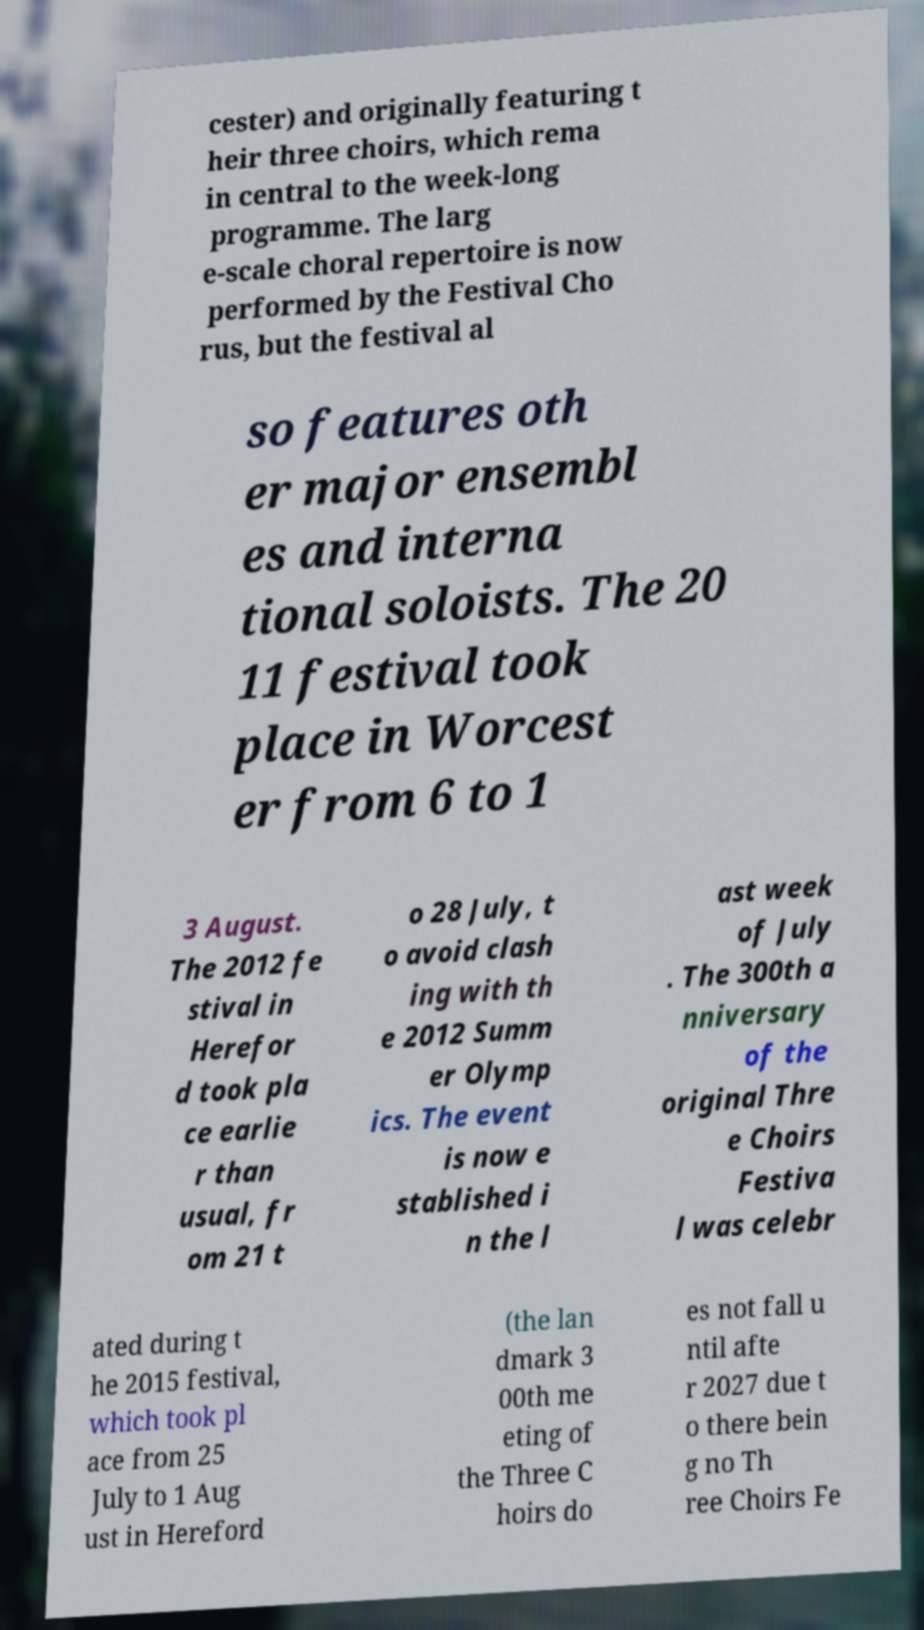What messages or text are displayed in this image? I need them in a readable, typed format. cester) and originally featuring t heir three choirs, which rema in central to the week-long programme. The larg e-scale choral repertoire is now performed by the Festival Cho rus, but the festival al so features oth er major ensembl es and interna tional soloists. The 20 11 festival took place in Worcest er from 6 to 1 3 August. The 2012 fe stival in Herefor d took pla ce earlie r than usual, fr om 21 t o 28 July, t o avoid clash ing with th e 2012 Summ er Olymp ics. The event is now e stablished i n the l ast week of July . The 300th a nniversary of the original Thre e Choirs Festiva l was celebr ated during t he 2015 festival, which took pl ace from 25 July to 1 Aug ust in Hereford (the lan dmark 3 00th me eting of the Three C hoirs do es not fall u ntil afte r 2027 due t o there bein g no Th ree Choirs Fe 